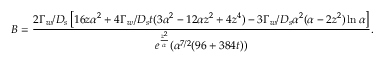Convert formula to latex. <formula><loc_0><loc_0><loc_500><loc_500>B = \frac { 2 \Gamma _ { w } / D _ { s } \left [ 1 6 z \alpha ^ { 2 } + 4 \Gamma _ { w } / D _ { s } t ( 3 \alpha ^ { 2 } - 1 2 \alpha z ^ { 2 } + 4 z ^ { 4 } ) - 3 \Gamma _ { w } / D _ { s } \alpha ^ { 2 } ( \alpha - 2 z ^ { 2 } ) \ln \alpha \right ] } { e ^ { \frac { z ^ { 2 } } { \alpha } } ( \alpha ^ { 7 / 2 } ( 9 6 + 3 8 4 t ) ) } .</formula> 